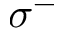Convert formula to latex. <formula><loc_0><loc_0><loc_500><loc_500>\sigma ^ { - }</formula> 